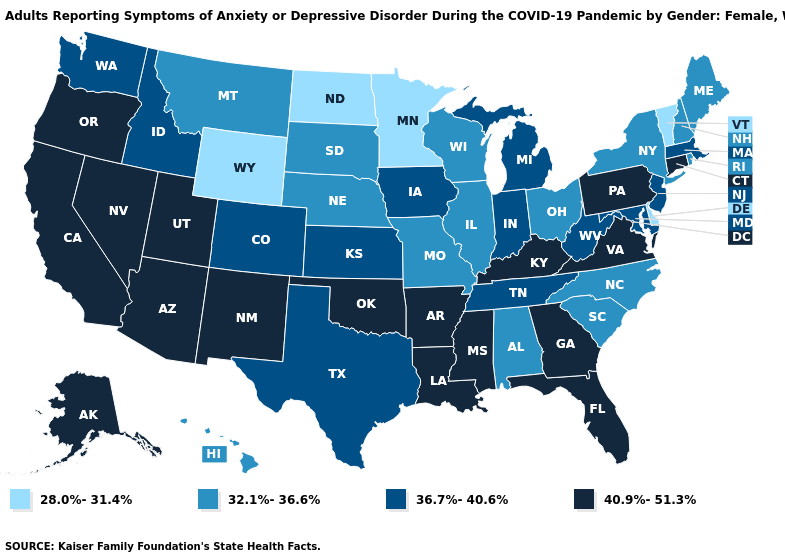What is the lowest value in states that border Texas?
Short answer required. 40.9%-51.3%. Name the states that have a value in the range 28.0%-31.4%?
Answer briefly. Delaware, Minnesota, North Dakota, Vermont, Wyoming. What is the highest value in the USA?
Answer briefly. 40.9%-51.3%. Which states have the lowest value in the West?
Keep it brief. Wyoming. Name the states that have a value in the range 40.9%-51.3%?
Short answer required. Alaska, Arizona, Arkansas, California, Connecticut, Florida, Georgia, Kentucky, Louisiana, Mississippi, Nevada, New Mexico, Oklahoma, Oregon, Pennsylvania, Utah, Virginia. Which states hav the highest value in the MidWest?
Be succinct. Indiana, Iowa, Kansas, Michigan. Name the states that have a value in the range 36.7%-40.6%?
Concise answer only. Colorado, Idaho, Indiana, Iowa, Kansas, Maryland, Massachusetts, Michigan, New Jersey, Tennessee, Texas, Washington, West Virginia. What is the value of Delaware?
Keep it brief. 28.0%-31.4%. What is the highest value in states that border Kentucky?
Answer briefly. 40.9%-51.3%. Among the states that border Wyoming , does Idaho have the lowest value?
Quick response, please. No. Name the states that have a value in the range 28.0%-31.4%?
Be succinct. Delaware, Minnesota, North Dakota, Vermont, Wyoming. What is the value of Vermont?
Be succinct. 28.0%-31.4%. Among the states that border Arkansas , which have the lowest value?
Keep it brief. Missouri. Name the states that have a value in the range 36.7%-40.6%?
Short answer required. Colorado, Idaho, Indiana, Iowa, Kansas, Maryland, Massachusetts, Michigan, New Jersey, Tennessee, Texas, Washington, West Virginia. What is the value of Maryland?
Answer briefly. 36.7%-40.6%. 